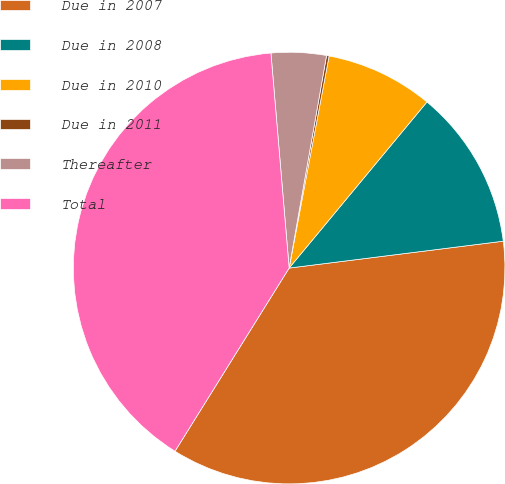Convert chart to OTSL. <chart><loc_0><loc_0><loc_500><loc_500><pie_chart><fcel>Due in 2007<fcel>Due in 2008<fcel>Due in 2010<fcel>Due in 2011<fcel>Thereafter<fcel>Total<nl><fcel>35.86%<fcel>11.99%<fcel>8.06%<fcel>0.19%<fcel>4.12%<fcel>39.79%<nl></chart> 